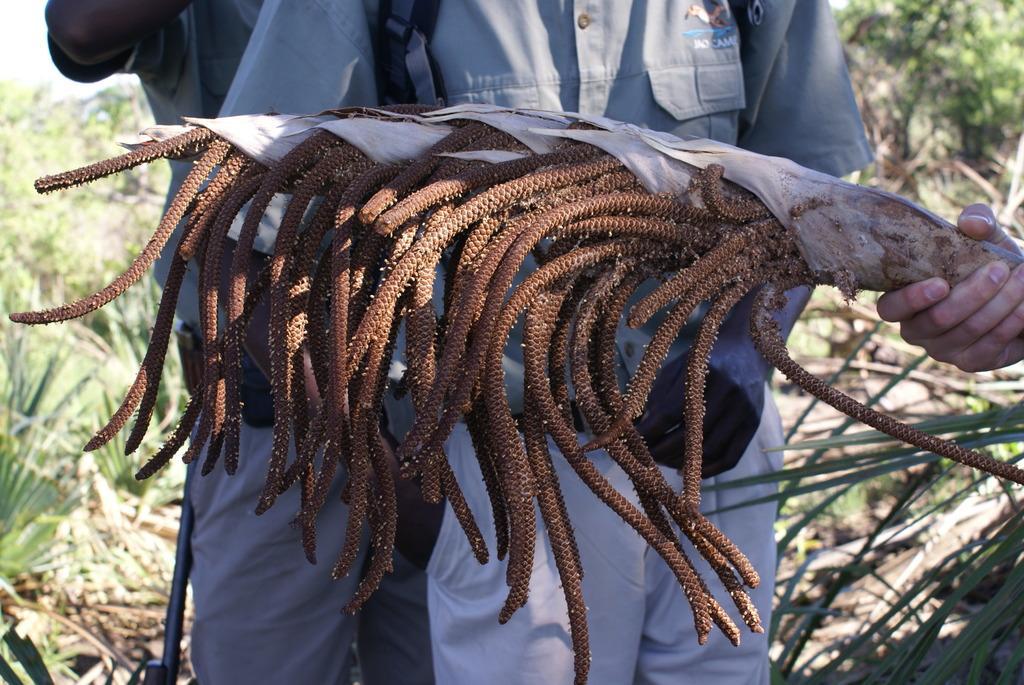Could you give a brief overview of what you see in this image? In the center of the image we can see two persons are standing and they are in different costumes. On the right side of the image, we can see a human hand holding some object. In the background, we can see plants. 